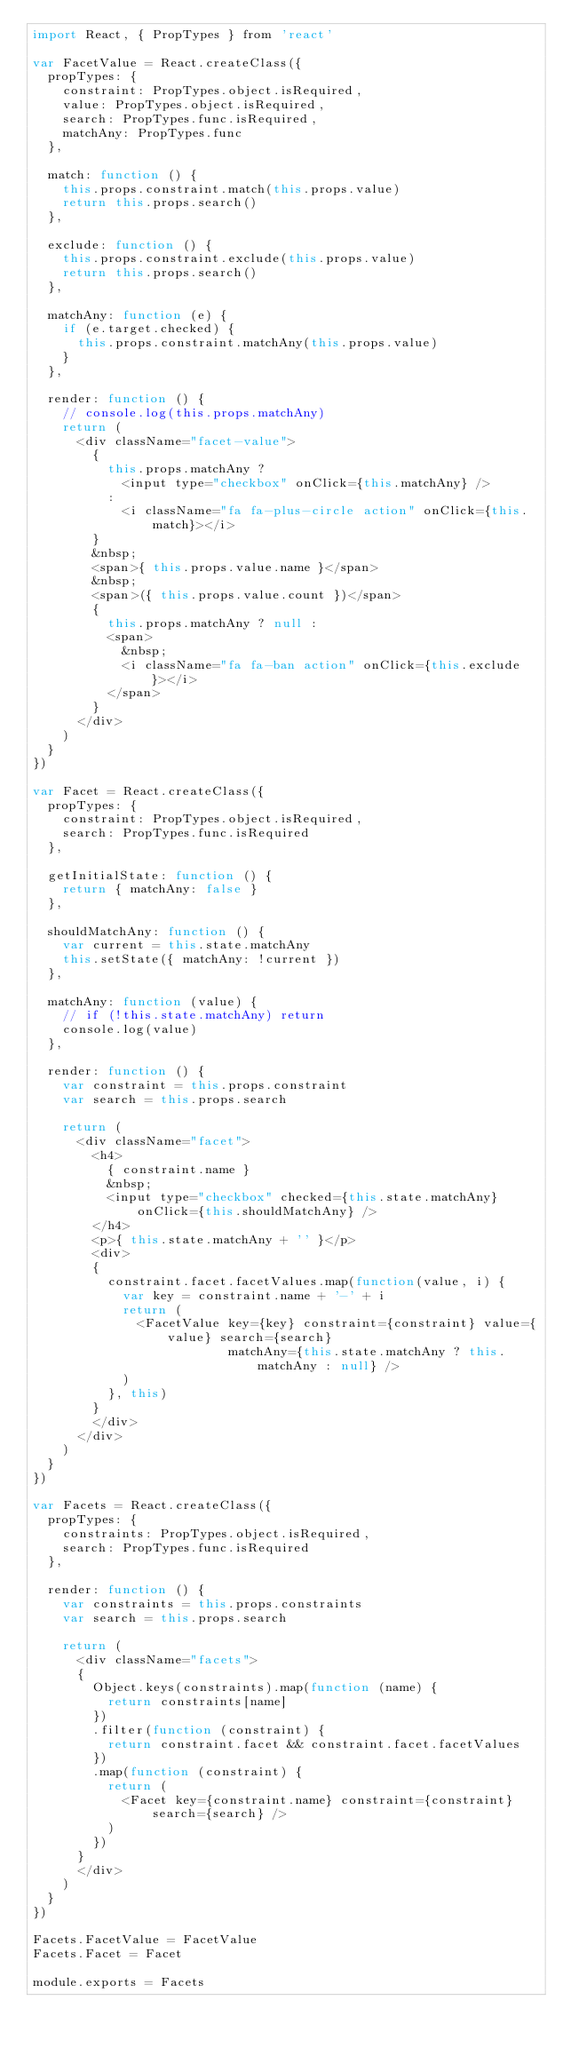<code> <loc_0><loc_0><loc_500><loc_500><_JavaScript_>import React, { PropTypes } from 'react'

var FacetValue = React.createClass({
  propTypes: {
    constraint: PropTypes.object.isRequired,
    value: PropTypes.object.isRequired,
    search: PropTypes.func.isRequired,
    matchAny: PropTypes.func
  },

  match: function () {
    this.props.constraint.match(this.props.value)
    return this.props.search()
  },

  exclude: function () {
    this.props.constraint.exclude(this.props.value)
    return this.props.search()
  },

  matchAny: function (e) {
    if (e.target.checked) {
      this.props.constraint.matchAny(this.props.value)
    }
  },

  render: function () {
    // console.log(this.props.matchAny)
    return (
      <div className="facet-value">
        {
          this.props.matchAny ?
            <input type="checkbox" onClick={this.matchAny} />
          :
            <i className="fa fa-plus-circle action" onClick={this.match}></i>
        }
        &nbsp;
        <span>{ this.props.value.name }</span>
        &nbsp;
        <span>({ this.props.value.count })</span>
        {
          this.props.matchAny ? null :
          <span>
            &nbsp;
            <i className="fa fa-ban action" onClick={this.exclude}></i>
          </span>
        }
      </div>
    )
  }
})

var Facet = React.createClass({
  propTypes: {
    constraint: PropTypes.object.isRequired,
    search: PropTypes.func.isRequired
  },

  getInitialState: function () {
    return { matchAny: false }
  },

  shouldMatchAny: function () {
    var current = this.state.matchAny
    this.setState({ matchAny: !current })
  },

  matchAny: function (value) {
    // if (!this.state.matchAny) return
    console.log(value)
  },

  render: function () {
    var constraint = this.props.constraint
    var search = this.props.search

    return (
      <div className="facet">
        <h4>
          { constraint.name }
          &nbsp;
          <input type="checkbox" checked={this.state.matchAny} onClick={this.shouldMatchAny} />
        </h4>
        <p>{ this.state.matchAny + '' }</p>
        <div>
        {
          constraint.facet.facetValues.map(function(value, i) {
            var key = constraint.name + '-' + i
            return (
              <FacetValue key={key} constraint={constraint} value={value} search={search}
                          matchAny={this.state.matchAny ? this.matchAny : null} />
            )
          }, this)
        }
        </div>
      </div>
    )
  }
})

var Facets = React.createClass({
  propTypes: {
    constraints: PropTypes.object.isRequired,
    search: PropTypes.func.isRequired
  },

  render: function () {
    var constraints = this.props.constraints
    var search = this.props.search

    return (
      <div className="facets">
      {
        Object.keys(constraints).map(function (name) {
          return constraints[name]
        })
        .filter(function (constraint) {
          return constraint.facet && constraint.facet.facetValues
        })
        .map(function (constraint) {
          return (
            <Facet key={constraint.name} constraint={constraint} search={search} />
          )
        })
      }
      </div>
    )
  }
})

Facets.FacetValue = FacetValue
Facets.Facet = Facet

module.exports = Facets
</code> 